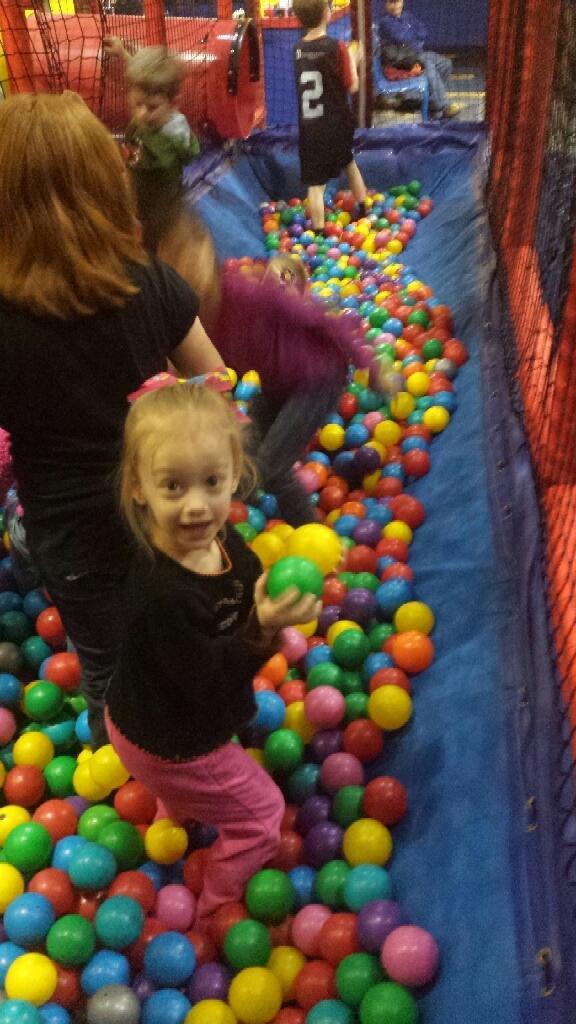Could you give a brief overview of what you see in this image? It is a kids play zone the kids are playing with color balls,there is a net around the kids and behind the net a person is sitting on a chair. 